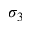<formula> <loc_0><loc_0><loc_500><loc_500>\sigma _ { 3 }</formula> 